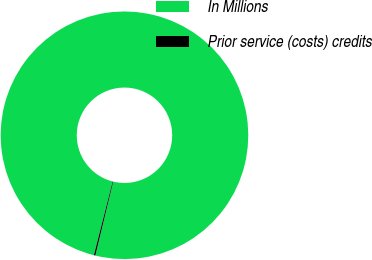Convert chart to OTSL. <chart><loc_0><loc_0><loc_500><loc_500><pie_chart><fcel>In Millions<fcel>Prior service (costs) credits<nl><fcel>99.81%<fcel>0.19%<nl></chart> 